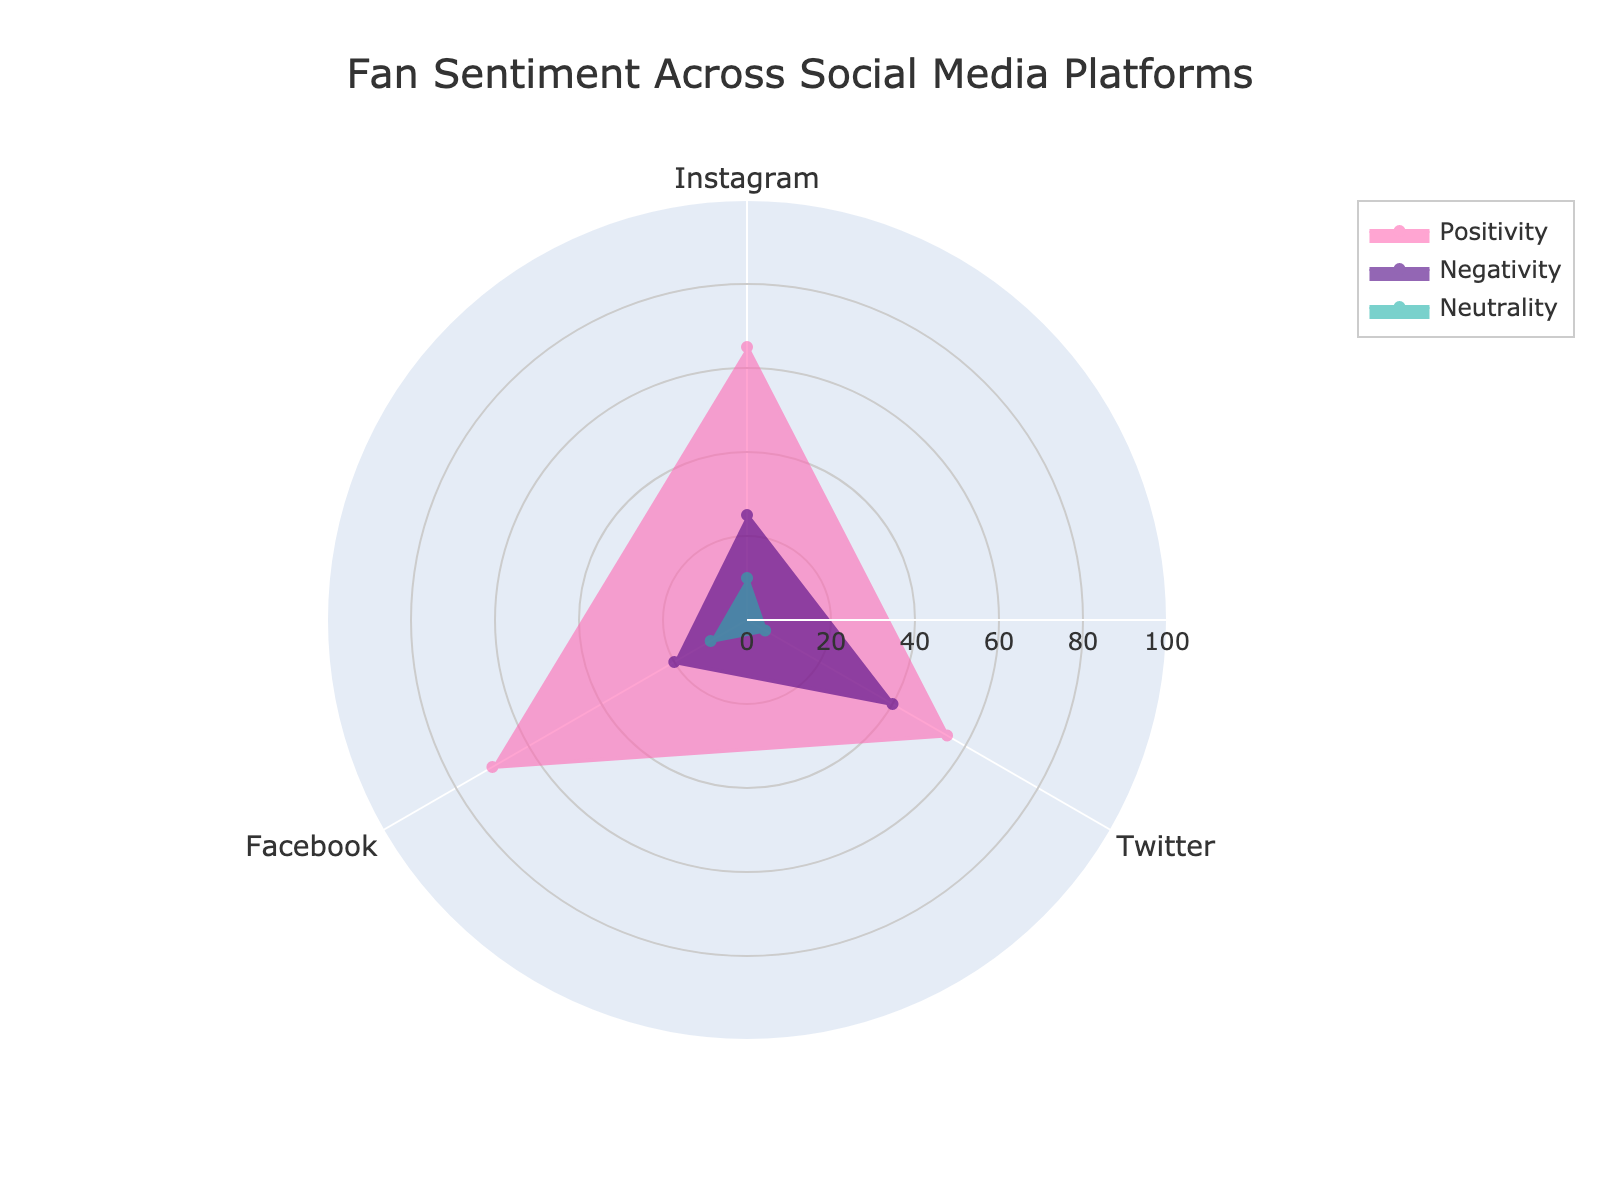What is the title of the radar chart? The title is usually mentioned at the top of the chart, and in this case, the title is "Fan Sentiment Across Social Media Platforms."
Answer: Fan Sentiment Across Social Media Platforms Which sentiment has the highest score on Facebook? Look at the plotted values for Facebook under the sentiment categories. Positivity has the highest score on Facebook with 70.
Answer: Positivity How does the positivity score on Twitter compare to Instagram? Compare the values of positivity for both Twitter and Instagram. Instagram has a positivity score of 65, while Twitter has a score of 55.
Answer: Instagram has a higher positivity score than Twitter What is the average negativity score across all platforms? Add the negativity scores for Instagram, Twitter, and Facebook, then divide by the number of platforms: (25 + 40 + 20) / 3 = 28.33.
Answer: 28.33 Which platform has the lowest neutrality score? Compare the neutrality scores of Instagram, Twitter, and Facebook. Twitter has the lowest neutrality score with a value of 5.
Answer: Twitter What is the total positivity score across all platforms? Add up the positivity scores for Instagram, Twitter, and Facebook: 65 + 55 + 70 = 190.
Answer: 190 How does the negativity score on Instagram compare to Facebook? Compare the values of negativity for both Instagram and Facebook. Instagram has a negativity score of 25, while Facebook has a score of 20.
Answer: Instagram is higher by 5 Which platforms have equal neutrality scores? Compare the neutrality scores among the platforms. Both Instagram and Facebook have a neutrality score of 10.
Answer: Instagram and Facebook What is the range of positivity scores across the platforms? Calculate the difference between the highest and lowest positivity scores: 70 (Facebook) - 55 (Twitter) = 15.
Answer: 15 Which sentiment category has the least variation across platforms? Check the variation in scores for each sentiment. Neutrality ranges from 5 to 10. Positivity ranges from 55 to 70, and Negativity ranges from 20 to 40. Neutrality has the least variation, ranging only from 5 to 10.
Answer: Neutrality 